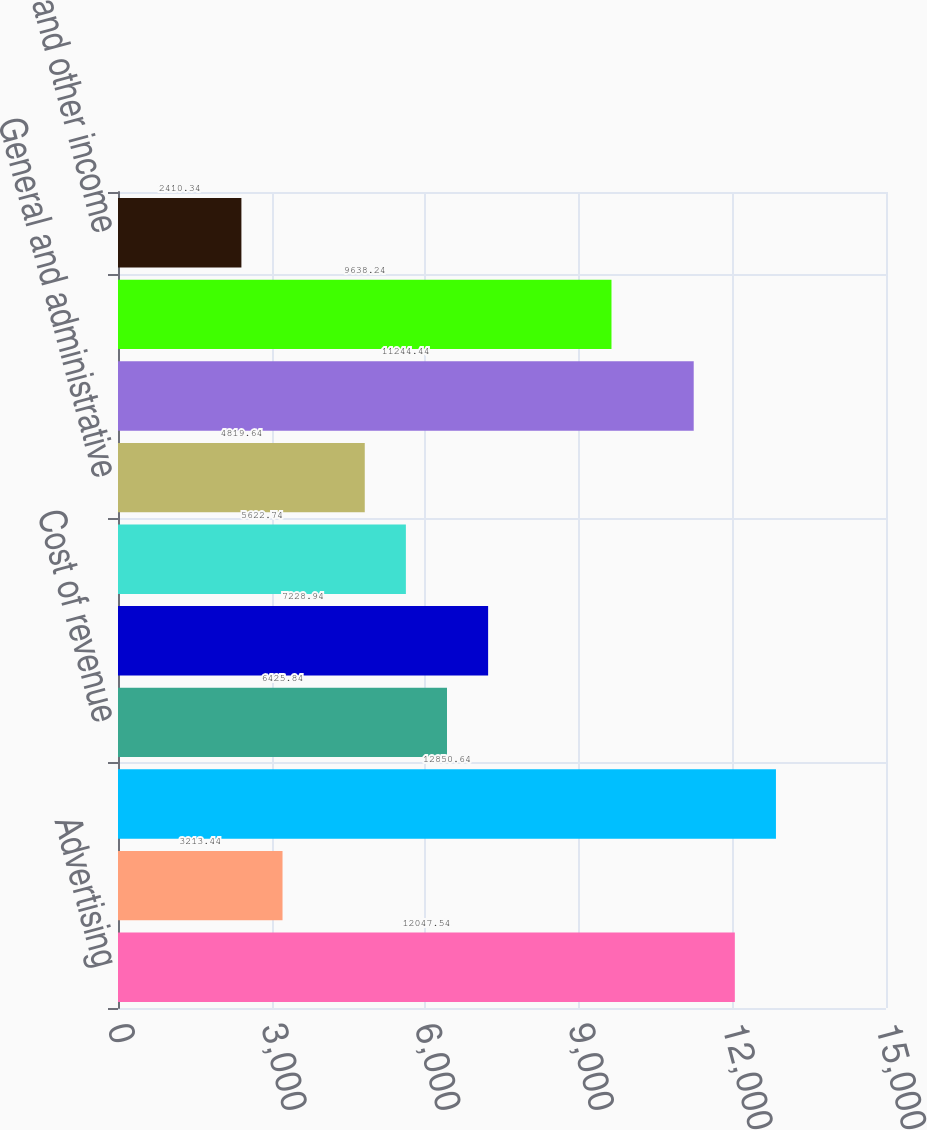Convert chart to OTSL. <chart><loc_0><loc_0><loc_500><loc_500><bar_chart><fcel>Advertising<fcel>Payments and other fees<fcel>Total revenue<fcel>Cost of revenue<fcel>Research and development<fcel>Marketing and sales<fcel>General and administrative<fcel>Total costs and expenses<fcel>Income from operations<fcel>Interest and other income<nl><fcel>12047.5<fcel>3213.44<fcel>12850.6<fcel>6425.84<fcel>7228.94<fcel>5622.74<fcel>4819.64<fcel>11244.4<fcel>9638.24<fcel>2410.34<nl></chart> 